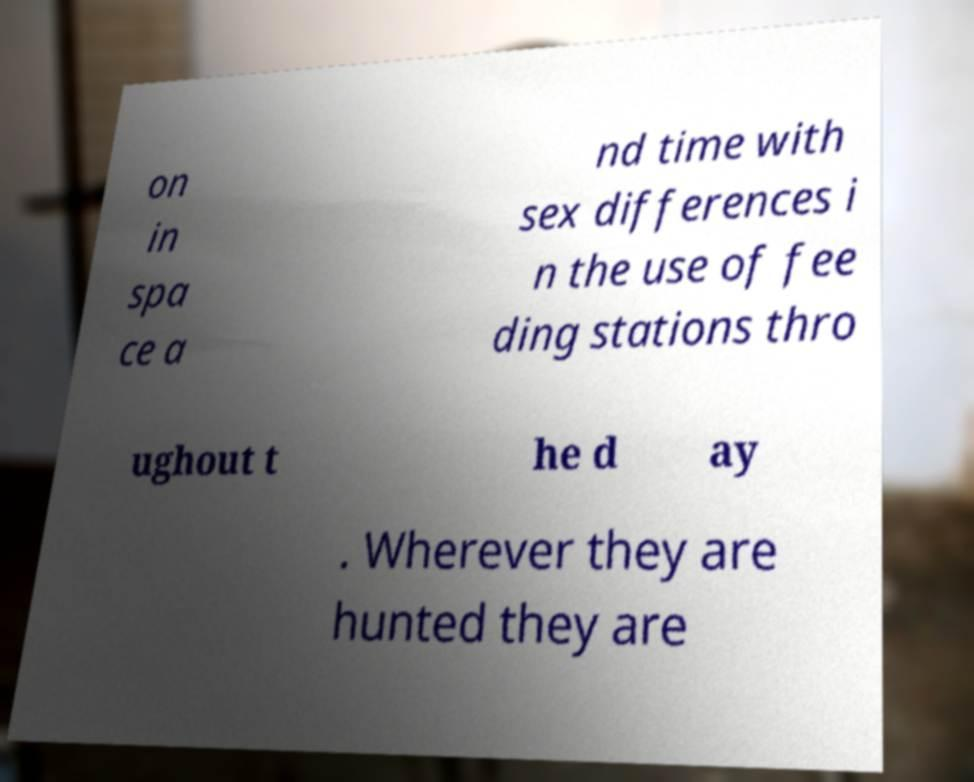Please read and relay the text visible in this image. What does it say? on in spa ce a nd time with sex differences i n the use of fee ding stations thro ughout t he d ay . Wherever they are hunted they are 